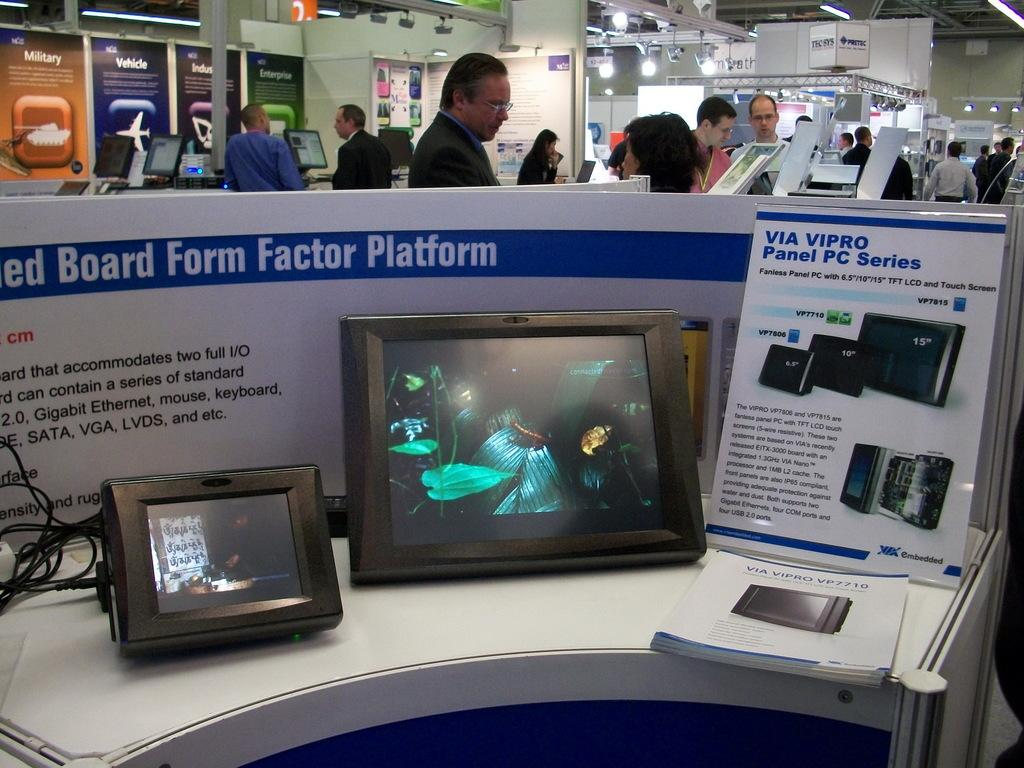<image>
Create a compact narrative representing the image presented. Two panel PCs displaying movies with an information guide about the PCs beside them. 